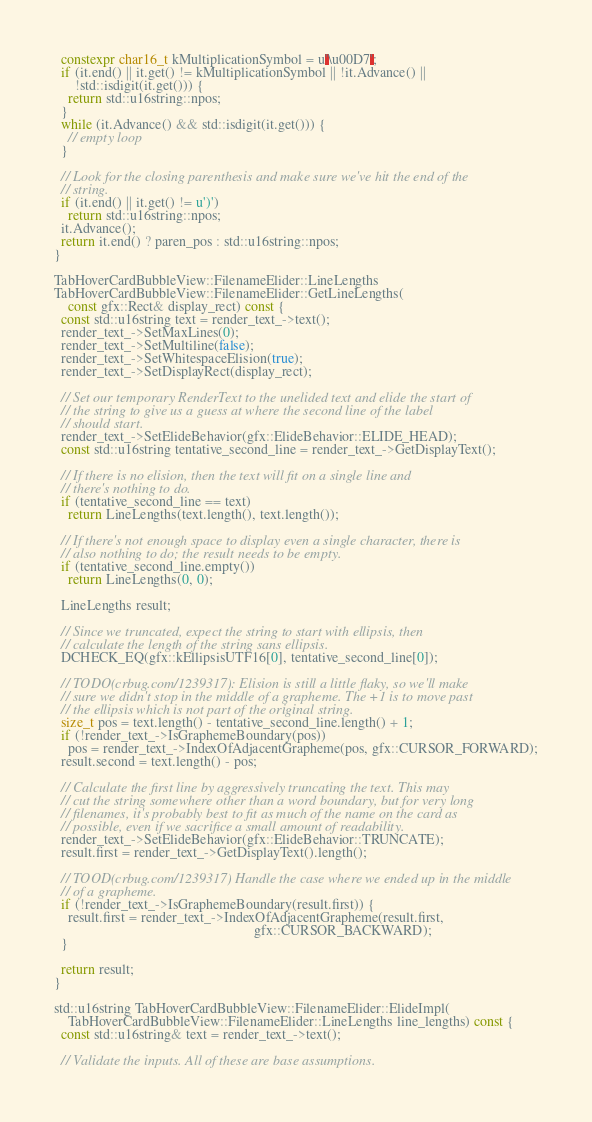Convert code to text. <code><loc_0><loc_0><loc_500><loc_500><_C++_>  constexpr char16_t kMultiplicationSymbol = u'\u00D7';
  if (it.end() || it.get() != kMultiplicationSymbol || !it.Advance() ||
      !std::isdigit(it.get())) {
    return std::u16string::npos;
  }
  while (it.Advance() && std::isdigit(it.get())) {
    // empty loop
  }

  // Look for the closing parenthesis and make sure we've hit the end of the
  // string.
  if (it.end() || it.get() != u')')
    return std::u16string::npos;
  it.Advance();
  return it.end() ? paren_pos : std::u16string::npos;
}

TabHoverCardBubbleView::FilenameElider::LineLengths
TabHoverCardBubbleView::FilenameElider::GetLineLengths(
    const gfx::Rect& display_rect) const {
  const std::u16string text = render_text_->text();
  render_text_->SetMaxLines(0);
  render_text_->SetMultiline(false);
  render_text_->SetWhitespaceElision(true);
  render_text_->SetDisplayRect(display_rect);

  // Set our temporary RenderText to the unelided text and elide the start of
  // the string to give us a guess at where the second line of the label
  // should start.
  render_text_->SetElideBehavior(gfx::ElideBehavior::ELIDE_HEAD);
  const std::u16string tentative_second_line = render_text_->GetDisplayText();

  // If there is no elision, then the text will fit on a single line and
  // there's nothing to do.
  if (tentative_second_line == text)
    return LineLengths(text.length(), text.length());

  // If there's not enough space to display even a single character, there is
  // also nothing to do; the result needs to be empty.
  if (tentative_second_line.empty())
    return LineLengths(0, 0);

  LineLengths result;

  // Since we truncated, expect the string to start with ellipsis, then
  // calculate the length of the string sans ellipsis.
  DCHECK_EQ(gfx::kEllipsisUTF16[0], tentative_second_line[0]);

  // TODO(crbug.com/1239317): Elision is still a little flaky, so we'll make
  // sure we didn't stop in the middle of a grapheme. The +1 is to move past
  // the ellipsis which is not part of the original string.
  size_t pos = text.length() - tentative_second_line.length() + 1;
  if (!render_text_->IsGraphemeBoundary(pos))
    pos = render_text_->IndexOfAdjacentGrapheme(pos, gfx::CURSOR_FORWARD);
  result.second = text.length() - pos;

  // Calculate the first line by aggressively truncating the text. This may
  // cut the string somewhere other than a word boundary, but for very long
  // filenames, it's probably best to fit as much of the name on the card as
  // possible, even if we sacrifice a small amount of readability.
  render_text_->SetElideBehavior(gfx::ElideBehavior::TRUNCATE);
  result.first = render_text_->GetDisplayText().length();

  // TOOD(crbug.com/1239317) Handle the case where we ended up in the middle
  // of a grapheme.
  if (!render_text_->IsGraphemeBoundary(result.first)) {
    result.first = render_text_->IndexOfAdjacentGrapheme(result.first,
                                                         gfx::CURSOR_BACKWARD);
  }

  return result;
}

std::u16string TabHoverCardBubbleView::FilenameElider::ElideImpl(
    TabHoverCardBubbleView::FilenameElider::LineLengths line_lengths) const {
  const std::u16string& text = render_text_->text();

  // Validate the inputs. All of these are base assumptions.</code> 